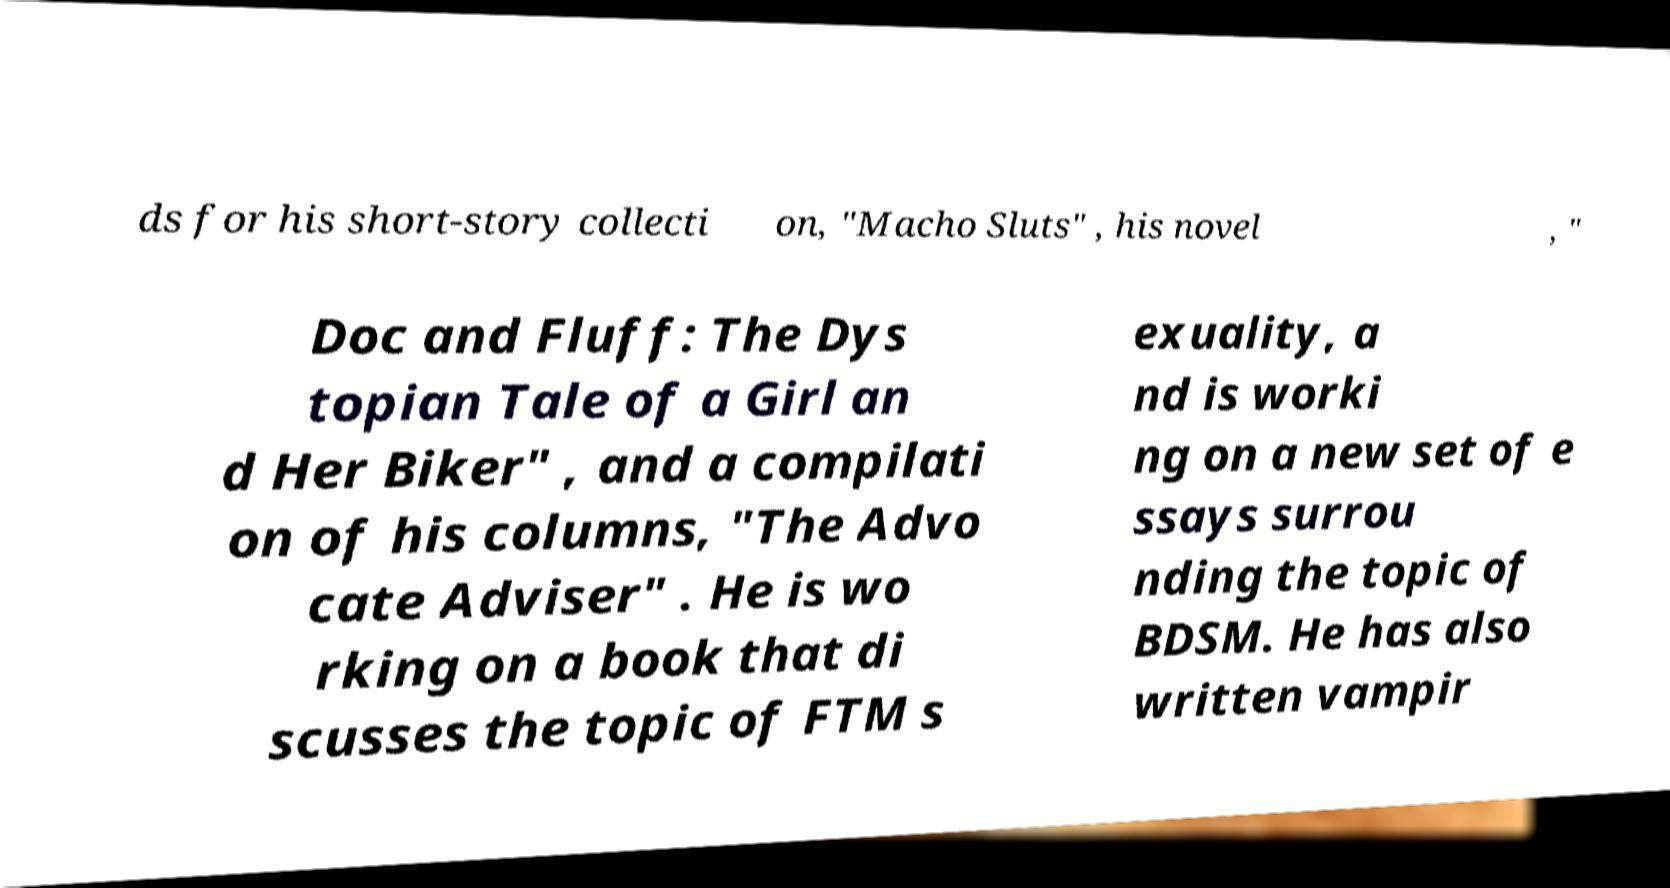Can you accurately transcribe the text from the provided image for me? ds for his short-story collecti on, "Macho Sluts" , his novel , " Doc and Fluff: The Dys topian Tale of a Girl an d Her Biker" , and a compilati on of his columns, "The Advo cate Adviser" . He is wo rking on a book that di scusses the topic of FTM s exuality, a nd is worki ng on a new set of e ssays surrou nding the topic of BDSM. He has also written vampir 